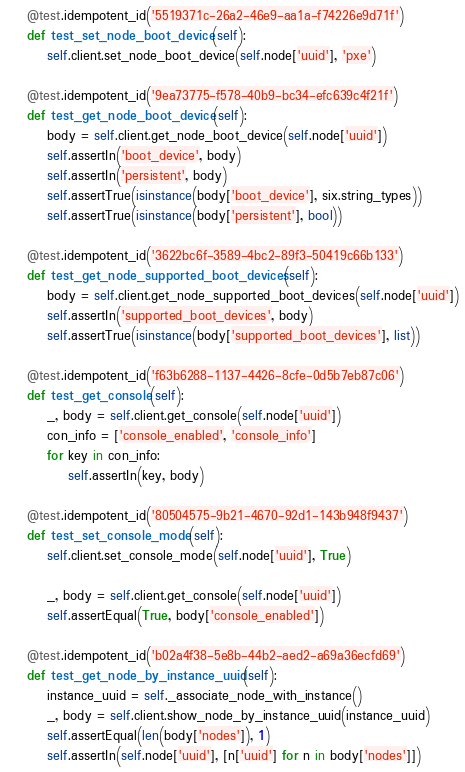Convert code to text. <code><loc_0><loc_0><loc_500><loc_500><_Python_>
    @test.idempotent_id('5519371c-26a2-46e9-aa1a-f74226e9d71f')
    def test_set_node_boot_device(self):
        self.client.set_node_boot_device(self.node['uuid'], 'pxe')

    @test.idempotent_id('9ea73775-f578-40b9-bc34-efc639c4f21f')
    def test_get_node_boot_device(self):
        body = self.client.get_node_boot_device(self.node['uuid'])
        self.assertIn('boot_device', body)
        self.assertIn('persistent', body)
        self.assertTrue(isinstance(body['boot_device'], six.string_types))
        self.assertTrue(isinstance(body['persistent'], bool))

    @test.idempotent_id('3622bc6f-3589-4bc2-89f3-50419c66b133')
    def test_get_node_supported_boot_devices(self):
        body = self.client.get_node_supported_boot_devices(self.node['uuid'])
        self.assertIn('supported_boot_devices', body)
        self.assertTrue(isinstance(body['supported_boot_devices'], list))

    @test.idempotent_id('f63b6288-1137-4426-8cfe-0d5b7eb87c06')
    def test_get_console(self):
        _, body = self.client.get_console(self.node['uuid'])
        con_info = ['console_enabled', 'console_info']
        for key in con_info:
            self.assertIn(key, body)

    @test.idempotent_id('80504575-9b21-4670-92d1-143b948f9437')
    def test_set_console_mode(self):
        self.client.set_console_mode(self.node['uuid'], True)

        _, body = self.client.get_console(self.node['uuid'])
        self.assertEqual(True, body['console_enabled'])

    @test.idempotent_id('b02a4f38-5e8b-44b2-aed2-a69a36ecfd69')
    def test_get_node_by_instance_uuid(self):
        instance_uuid = self._associate_node_with_instance()
        _, body = self.client.show_node_by_instance_uuid(instance_uuid)
        self.assertEqual(len(body['nodes']), 1)
        self.assertIn(self.node['uuid'], [n['uuid'] for n in body['nodes']])
</code> 